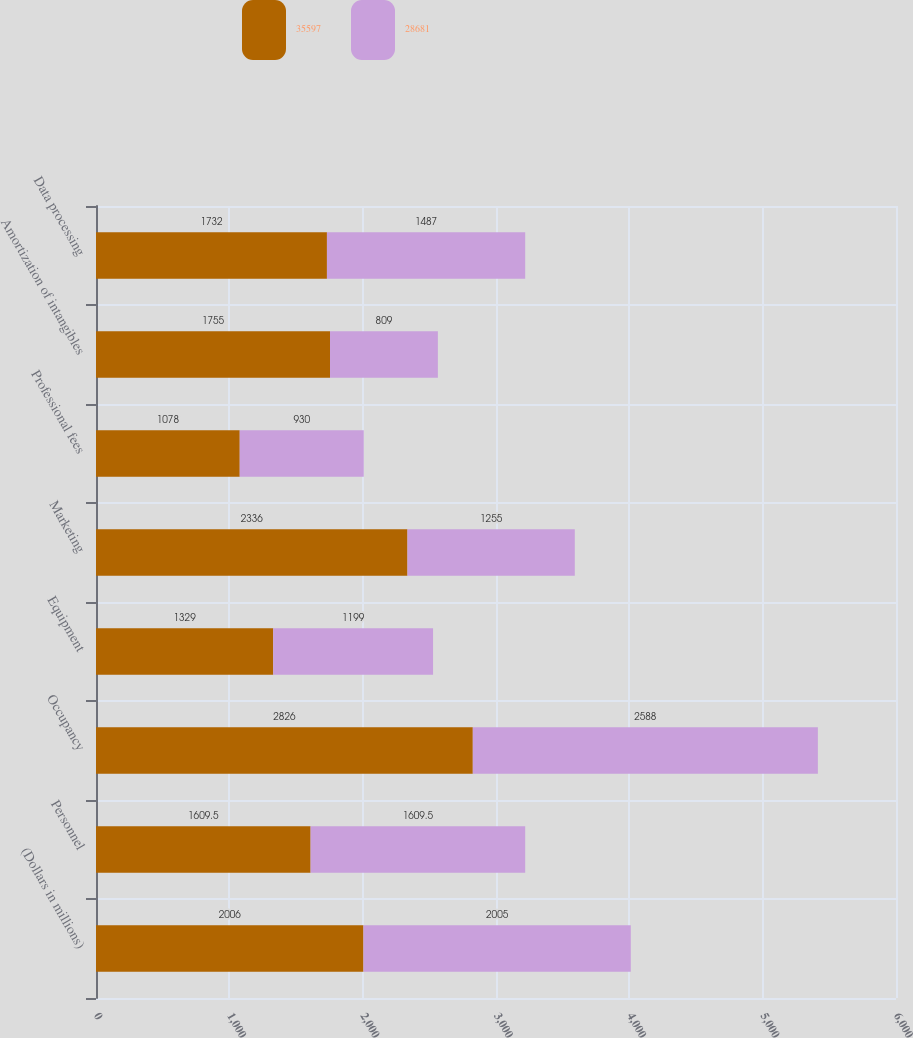<chart> <loc_0><loc_0><loc_500><loc_500><stacked_bar_chart><ecel><fcel>(Dollars in millions)<fcel>Personnel<fcel>Occupancy<fcel>Equipment<fcel>Marketing<fcel>Professional fees<fcel>Amortization of intangibles<fcel>Data processing<nl><fcel>35597<fcel>2006<fcel>1609.5<fcel>2826<fcel>1329<fcel>2336<fcel>1078<fcel>1755<fcel>1732<nl><fcel>28681<fcel>2005<fcel>1609.5<fcel>2588<fcel>1199<fcel>1255<fcel>930<fcel>809<fcel>1487<nl></chart> 